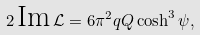Convert formula to latex. <formula><loc_0><loc_0><loc_500><loc_500>2 \, \text {Im} \, \mathcal { L } = 6 \pi ^ { 2 } q Q \cosh ^ { 3 } { \psi } ,</formula> 